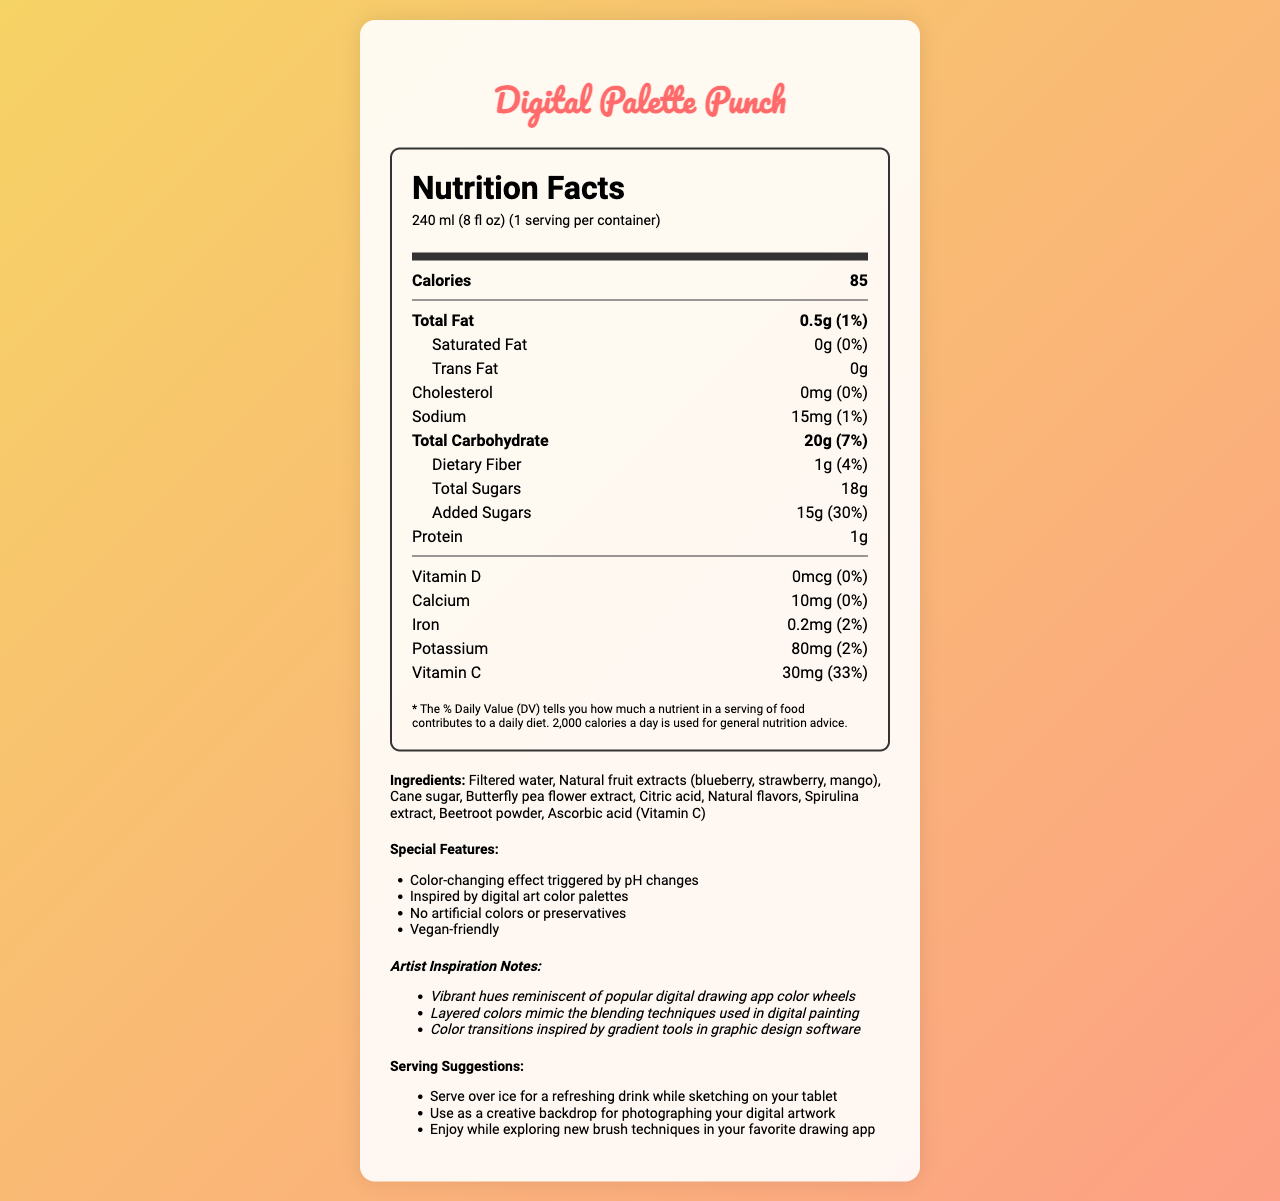how many servings are in a container of Digital Palette Punch? The serving size is listed as "240 ml (8 fl oz)" and "servings per container" is noted as 1.
Answer: 1 how many calories are in one serving of Digital Palette Punch? The nutrition facts label states there are 85 calories per serving.
Answer: 85 what is the total fat content in a serving of Digital Palette Punch? The nutrition facts label shows "Total Fat: 0.5g".
Answer: 0.5g what vitamins are included in Digital Palette Punch and their respective daily values? The nutrition facts label lists each vitamin along with its daily value percentage.
Answer: Vitamin D (0%), Calcium (0%), Iron (2%), Potassium (2%), Vitamin C (33%) what are the main ingredients of Digital Palette Punch? The ingredients list provides these main ingredients.
Answer: Filtered water, Natural fruit extracts (blueberry, strawberry, mango), Cane sugar, Butterfly pea flower extract, Citric acid, Natural flavors, Spirulina extract, Beetroot powder, Ascorbic acid (Vitamin C) which feature of Digital Palette Punch is inspired by digital art? A. No artificial colors B. Color-changing effect C. Vegan-friendly D. Low Calorie The document mentions "Color-changing effect triggered by pH changes" as a feature inspired by digital art color palettes.
Answer: B what is the added sugars daily value percentage in Digital Palette Punch? A. 7% B. 15% C. 30% D. 50% The nutrition facts label shows "Added Sugars: 15g (30%)".
Answer: C does Digital Palette Punch contain any cholesterol? The nutrition facts label indicates "Cholesterol: 0mg".
Answer: No are there any traces of tree nuts or soy in Digital Palette Punch? The allergen info states it is produced in a facility that processes tree nuts and soy.
Answer: Yes describe the special features of Digital Palette Punch. The document lists these special features in a bulleted format.
Answer: Color-changing effect triggered by pH changes, Inspired by digital art color palettes, No artificial colors or preservatives, Vegan-friendly what is the primary benefit of the 'color-changing effect' special feature? The document highlights this as part of the special features inspired by digital art.
Answer: Inspired by digital art palettes and integrates the visual creativity into the drinking experience how many grams of protein are in Digital Palette Punch? The nutrition facts label specifies "Protein: 1g".
Answer: 1g can I find the price of Digital Palette Punch on this document? The document does not provide any details regarding the price.
Answer: Not enough information what is the role of Butterfly pea flower extract in Digital Palette Punch? The special features section notes that the color-changing effect is a primary aspect, and Butterfly pea flower extract is typically used for this purpose.
Answer: Create the color-changing effect what is one way to consume Digital Palette Punch for a creative person? The serving suggestions highlight various ways, including enjoying it while sketching on a tablet.
Answer: Serve over ice for a refreshing drink while sketching on your tablet 